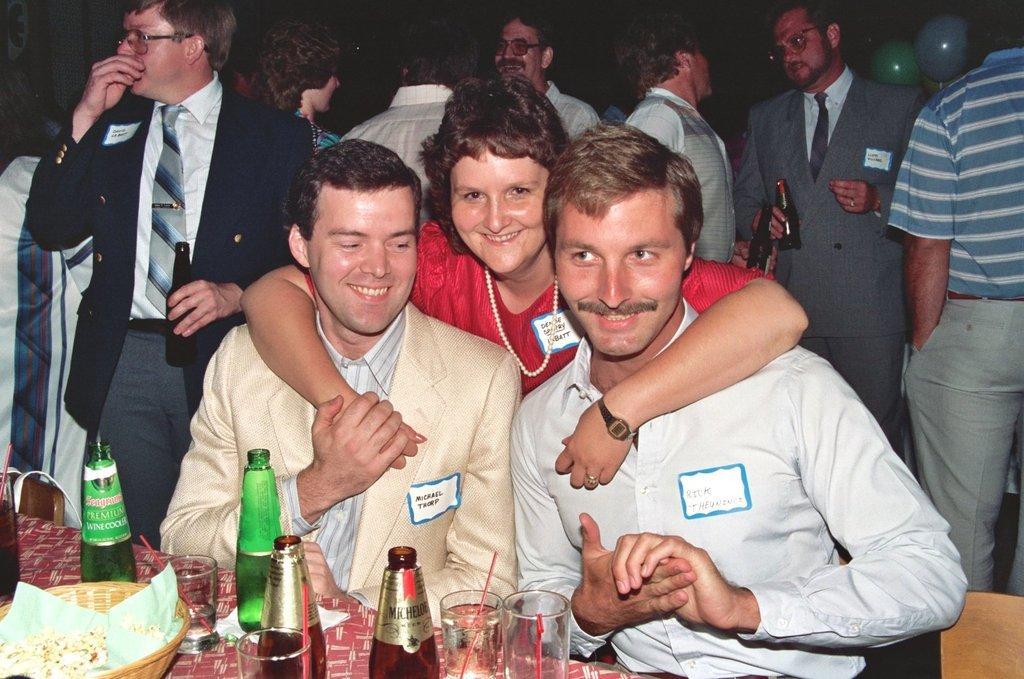How would you summarize this image in a sentence or two? In this image, we can see persons wearing clothes. There is a table at the bottom of the image contains glasses, bottles and basket. There are balloons in the top right of the image. There are some persons holding bottles with their hands. 